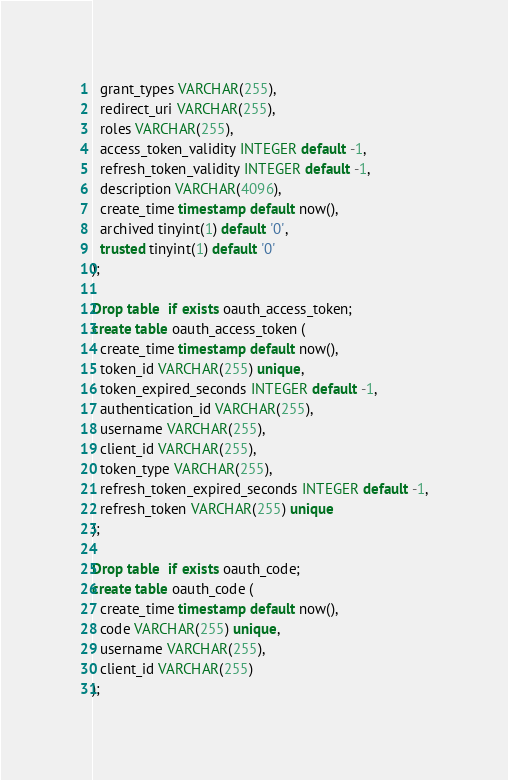<code> <loc_0><loc_0><loc_500><loc_500><_SQL_>  grant_types VARCHAR(255),
  redirect_uri VARCHAR(255),
  roles VARCHAR(255),
  access_token_validity INTEGER default -1,
  refresh_token_validity INTEGER default -1,
  description VARCHAR(4096),
  create_time timestamp default now(),
  archived tinyint(1) default '0',
  trusted tinyint(1) default '0'
);

Drop table  if exists oauth_access_token;
create table oauth_access_token (
  create_time timestamp default now(),
  token_id VARCHAR(255) unique,
  token_expired_seconds INTEGER default -1,
  authentication_id VARCHAR(255),
  username VARCHAR(255),
  client_id VARCHAR(255),
  token_type VARCHAR(255),
  refresh_token_expired_seconds INTEGER default -1,
  refresh_token VARCHAR(255) unique
);

Drop table  if exists oauth_code;
create table oauth_code (
  create_time timestamp default now(),
  code VARCHAR(255) unique,
  username VARCHAR(255),
  client_id VARCHAR(255)
);





</code> 